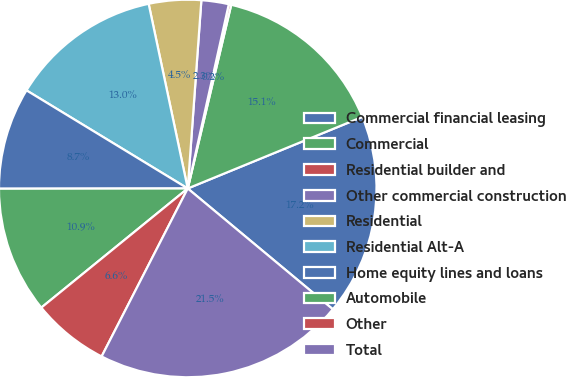Convert chart to OTSL. <chart><loc_0><loc_0><loc_500><loc_500><pie_chart><fcel>Commercial financial leasing<fcel>Commercial<fcel>Residential builder and<fcel>Other commercial construction<fcel>Residential<fcel>Residential Alt-A<fcel>Home equity lines and loans<fcel>Automobile<fcel>Other<fcel>Total<nl><fcel>17.24%<fcel>15.11%<fcel>0.21%<fcel>2.34%<fcel>4.47%<fcel>12.98%<fcel>8.72%<fcel>10.85%<fcel>6.59%<fcel>21.49%<nl></chart> 